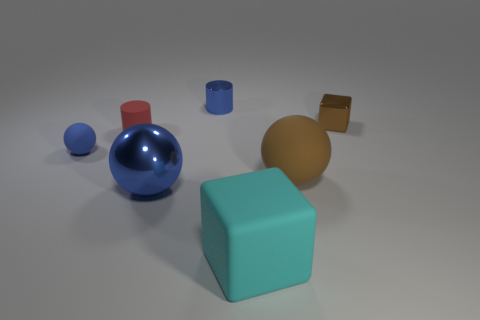How many cyan rubber cubes have the same size as the shiny cube?
Your response must be concise. 0. The metal thing that is the same color as the small metal cylinder is what size?
Provide a succinct answer. Large. How many tiny things are either blocks or brown objects?
Your answer should be very brief. 1. How many big blocks are there?
Your answer should be compact. 1. Are there the same number of cyan cubes to the left of the matte cube and tiny metal cylinders that are to the left of the big blue thing?
Your response must be concise. Yes. There is a metal cylinder; are there any metallic spheres to the left of it?
Ensure brevity in your answer.  Yes. There is a small shiny object to the left of the big brown thing; what color is it?
Your answer should be very brief. Blue. There is a thing right of the sphere to the right of the small blue shiny thing; what is it made of?
Keep it short and to the point. Metal. Are there fewer tiny matte things right of the blue metal cylinder than small rubber objects that are in front of the red cylinder?
Offer a very short reply. Yes. What number of blue objects are either tiny blocks or balls?
Your answer should be very brief. 2. 